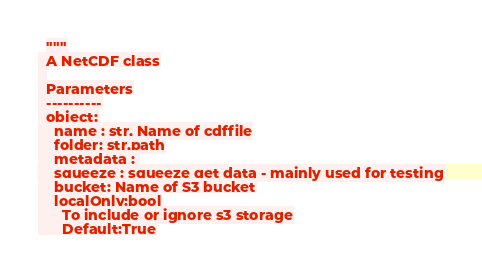Convert code to text. <code><loc_0><loc_0><loc_500><loc_500><_Python_>  """
  A NetCDF class
  
  Parameters
  ----------
  object:
    name : str, Name of cdffile
    folder: str,path
    metadata : 
    squeeze : squeeze get data - mainly used for testing
    bucket: Name of S3 bucket
    localOnly:bool
      To include or ignore s3 storage
      Default:True</code> 